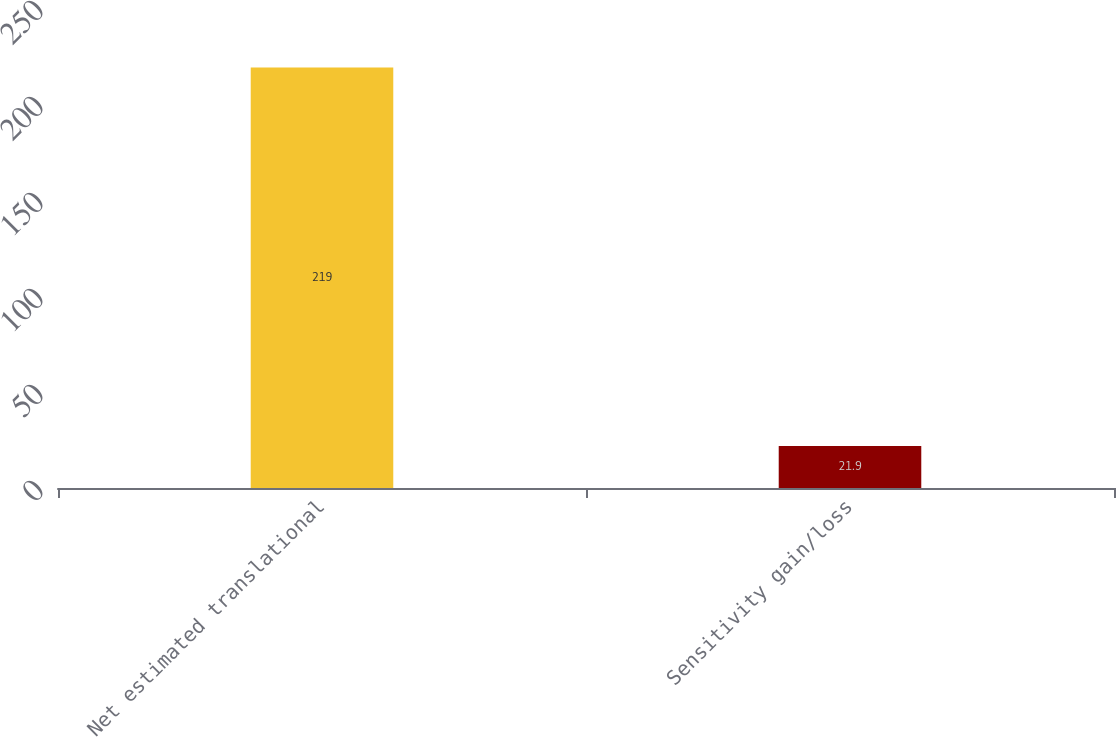Convert chart. <chart><loc_0><loc_0><loc_500><loc_500><bar_chart><fcel>Net estimated translational<fcel>Sensitivity gain/loss<nl><fcel>219<fcel>21.9<nl></chart> 